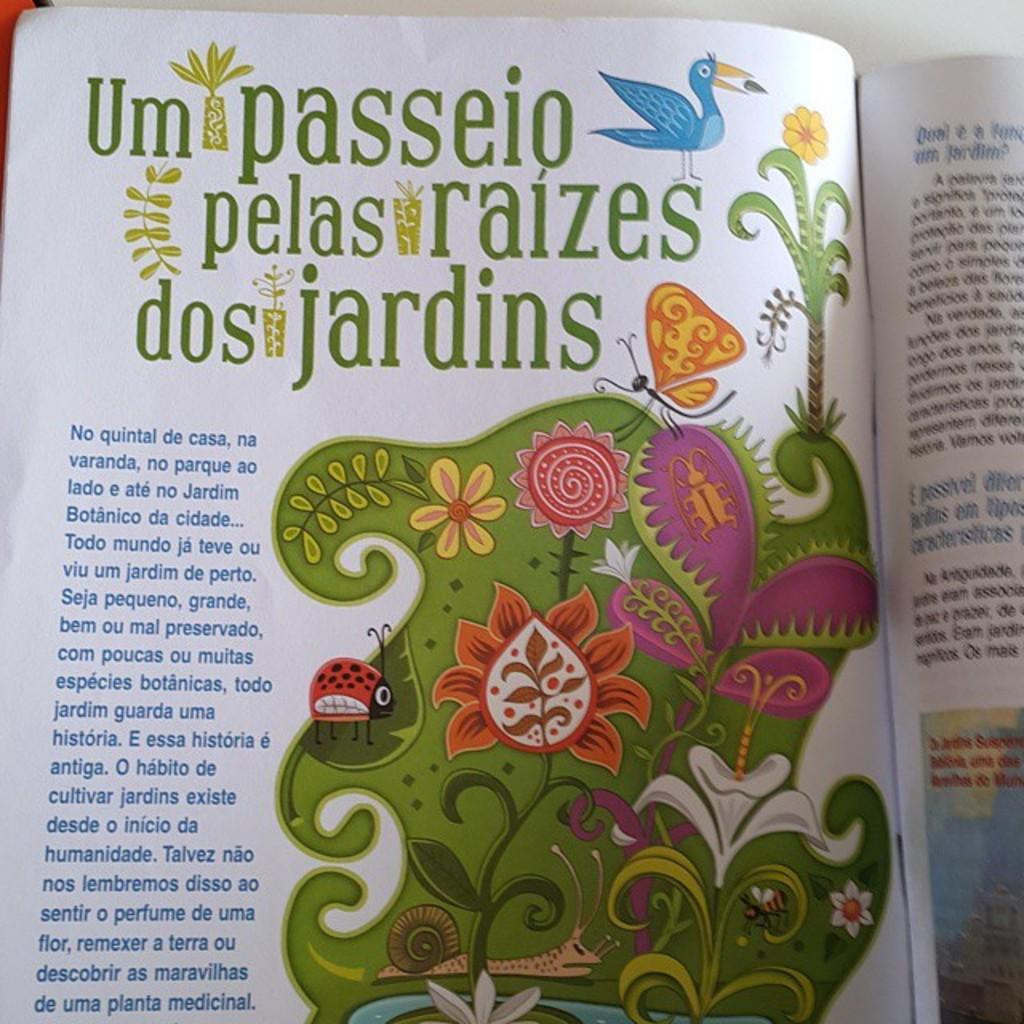Provide a one-sentence caption for the provided image. A colorful printed page written in Spanish discusses botanicas and jardins. 